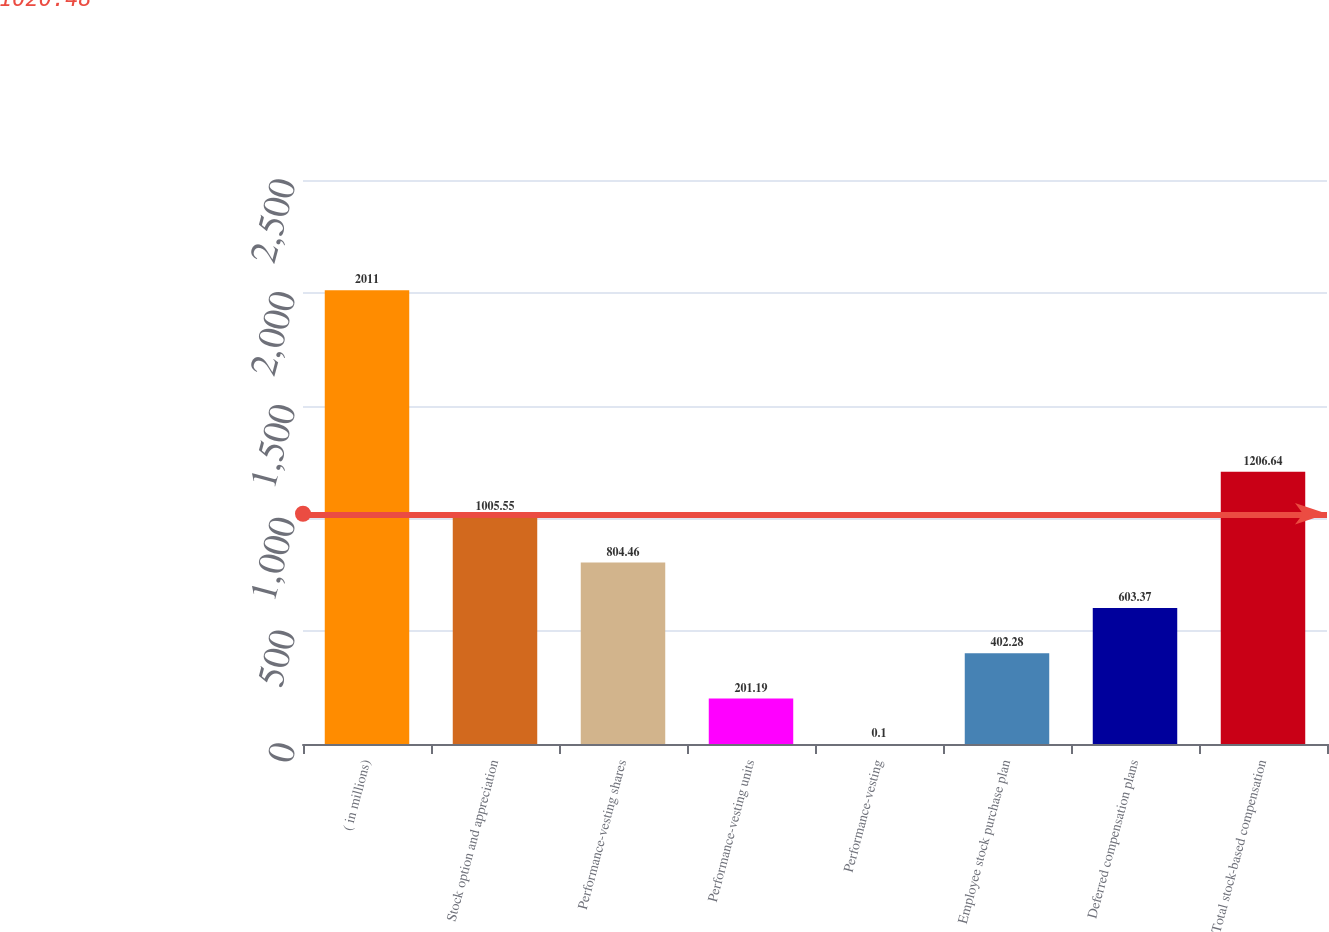Convert chart. <chart><loc_0><loc_0><loc_500><loc_500><bar_chart><fcel>( in millions)<fcel>Stock option and appreciation<fcel>Performance-vesting shares<fcel>Performance-vesting units<fcel>Performance-vesting<fcel>Employee stock purchase plan<fcel>Deferred compensation plans<fcel>Total stock-based compensation<nl><fcel>2011<fcel>1005.55<fcel>804.46<fcel>201.19<fcel>0.1<fcel>402.28<fcel>603.37<fcel>1206.64<nl></chart> 